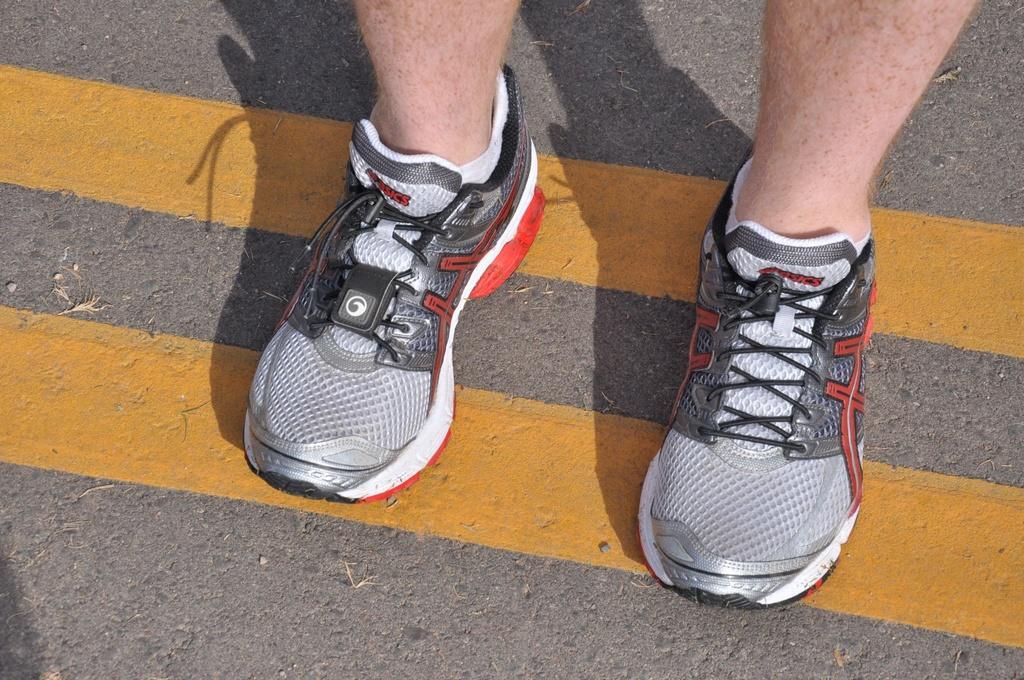How would you summarize this image in a sentence or two? In the image there is a road with yellow color lines. On the road there are person legs with shoes. 